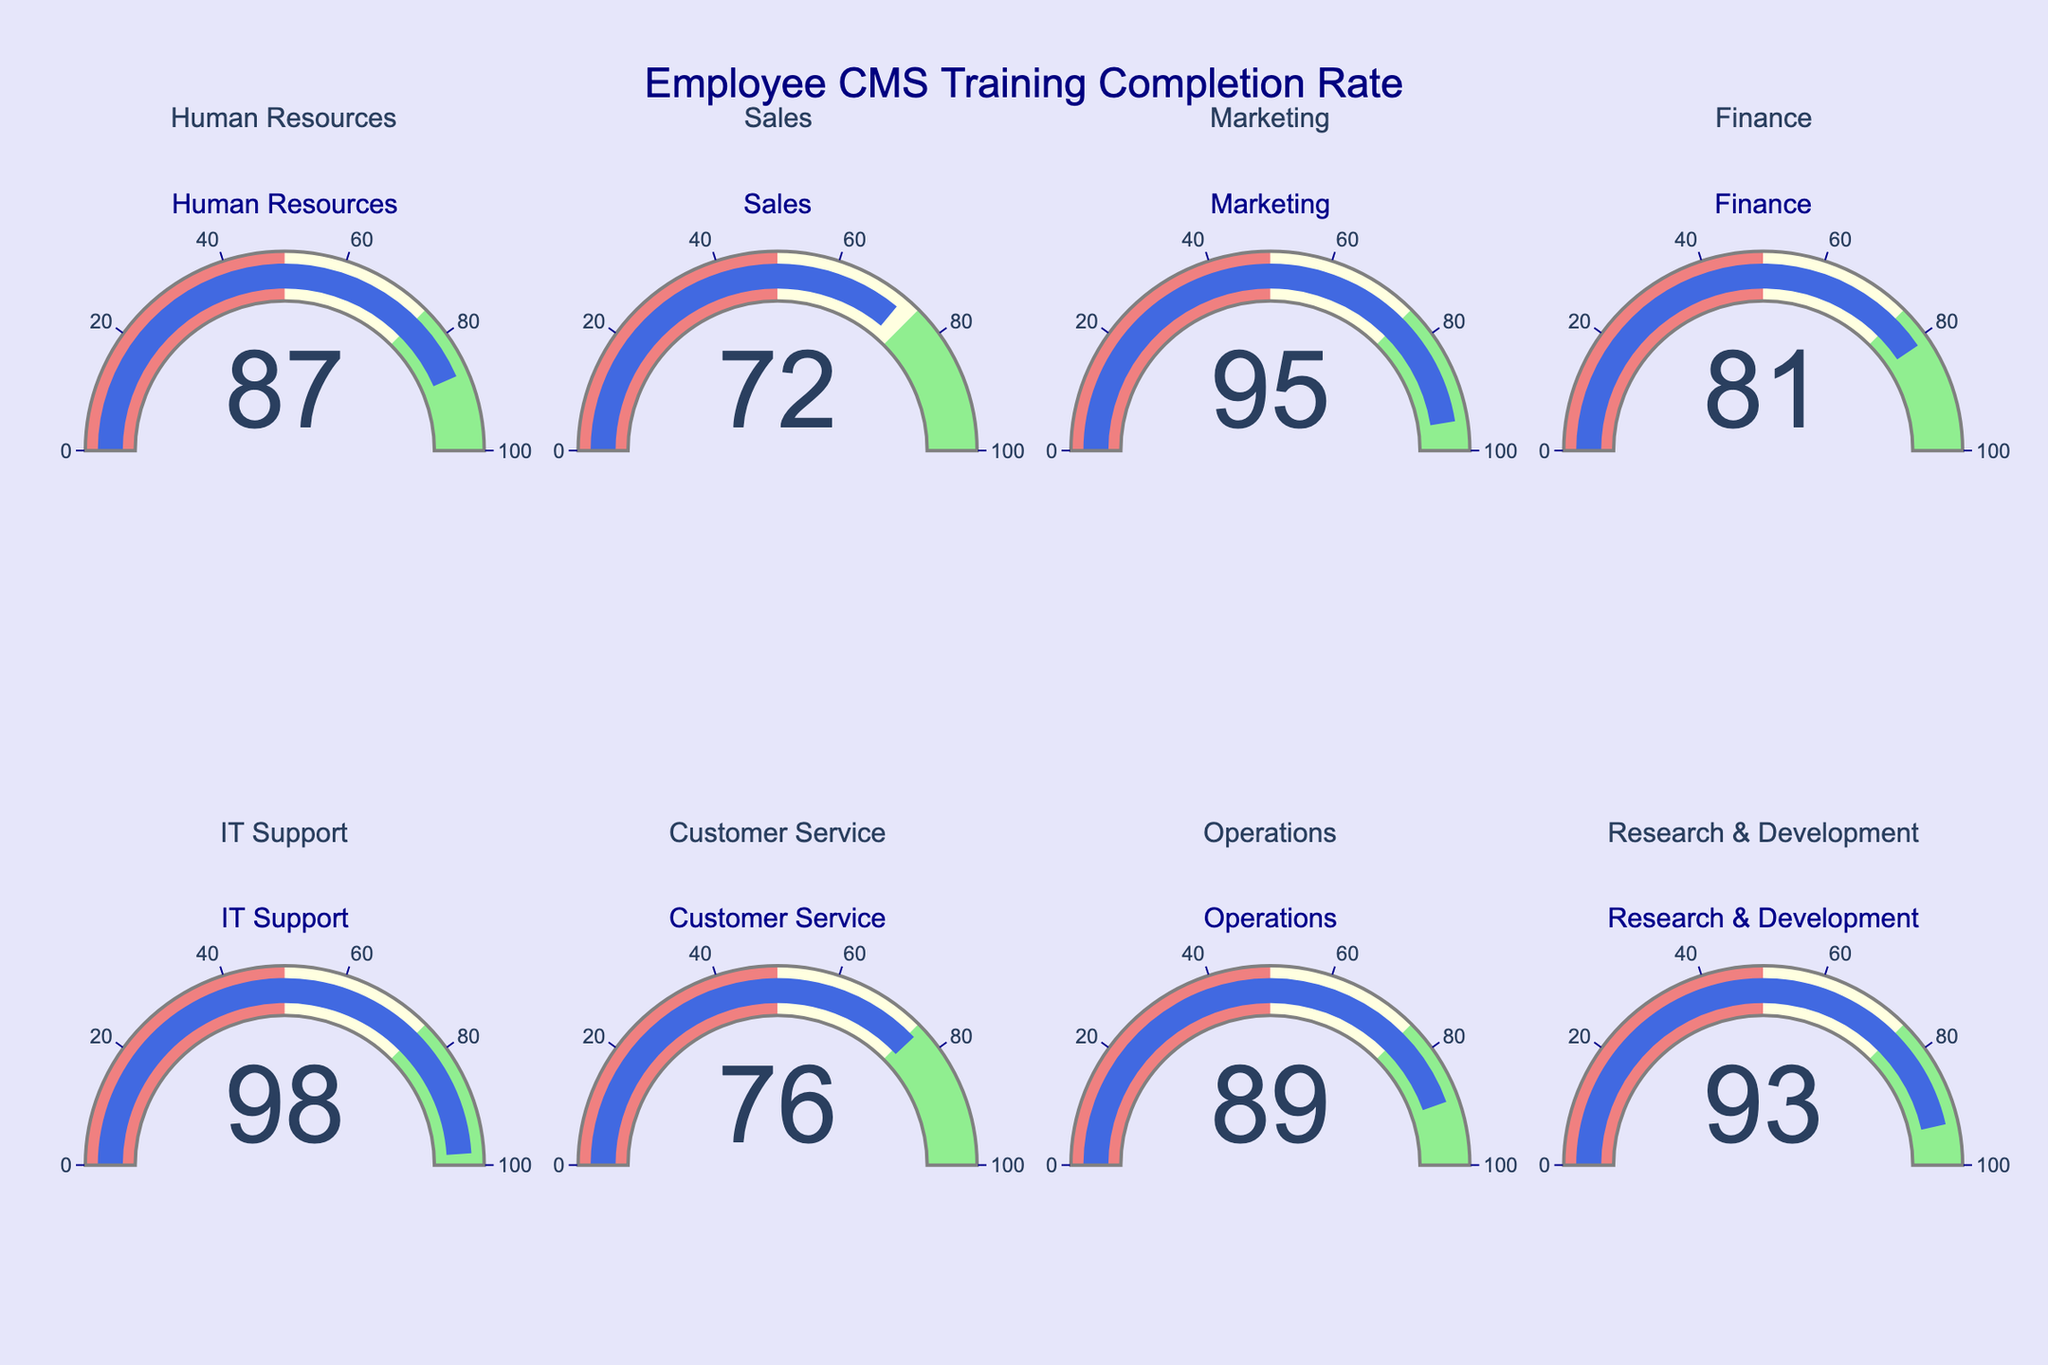What is the completion rate for the Marketing department? The Marketing department's gauge shows a completion rate. Observing the gauge shows that the value is 95.
Answer: 95 Which department has the highest training completion rate? From all displayed gauges and values, IT Support has the highest rate at 98%.
Answer: IT Support Is there any department with a completion rate below 70%? By looking at each gauge and value, all departments have completion rates above 70%.
Answer: No What is the average completion rate across all departments? Sum the completion rates (87 + 72 + 95 + 81 + 98 + 76 + 89 + 93 = 691) and divide by the number of departments (8). 691 / 8 = 86.375
Answer: 86.375 Which department has the lowest training completion rate? The Sales department has the lowest completion rate, at 72%.
Answer: Sales Compare the completion rates of the Finance and Customer Service departments. Which one is higher and by how much? Finance has a rate of 81, Customer Service 76. Subtract 76 from 81 to find the difference (81 - 76 = 5).
Answer: Finance by 5 How many departments have a completion rate above 90%? Observing the gauges, we see three departments above 90%: Marketing (95), IT Support (98), and Research & Development (93).
Answer: 3 What's the completion rate range across all departments? The highest rate is 98 (IT Support) and the lowest is 72 (Sales). So, the range is 98 - 72 = 26.
Answer: 26 Which departments fall into the 75-100% gauge section? Gauges for Human Resources (87), Marketing (95), Finance (81), IT Support (98), Operations (89), and Research & Development (93) are within this section.
Answer: Six departments Compare the completion rates of Operations and Research & Development. Are they the same or different, and by how much? Operations has a rate of 89, Research & Development 93. Subtract 89 from 93 to find the difference (93 - 89 = 4).
Answer: Different by 4 